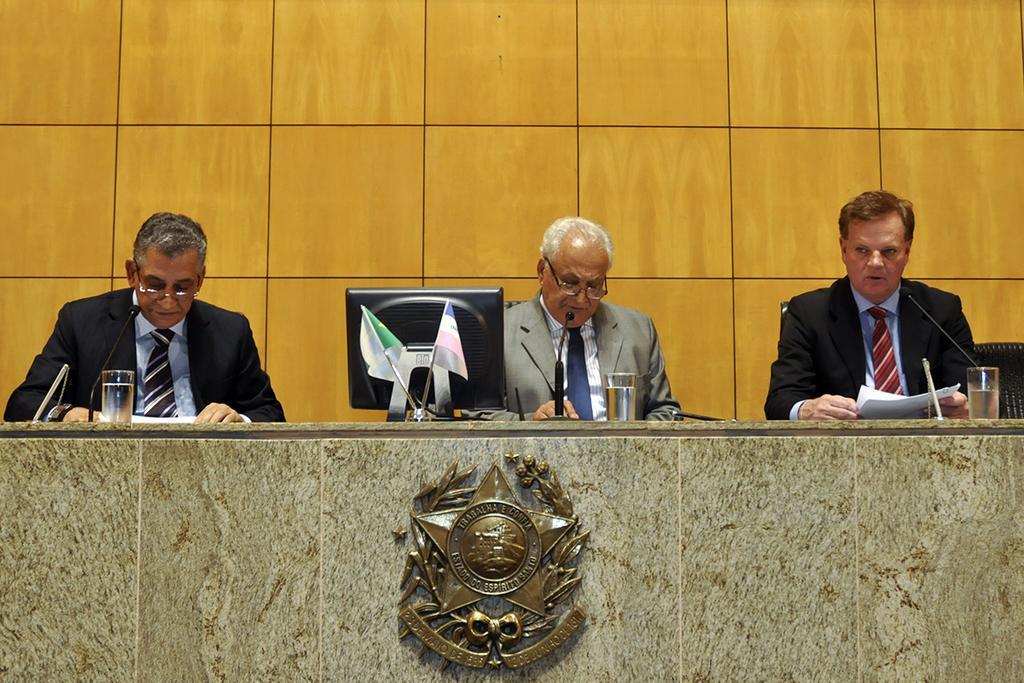Can you describe this image briefly? In this image in the center there are three persons sitting, and in front of them there is a table. On the table there are glasses, computer, mikes and one person is holding papers and there are some papers. And in the background there is wall. 